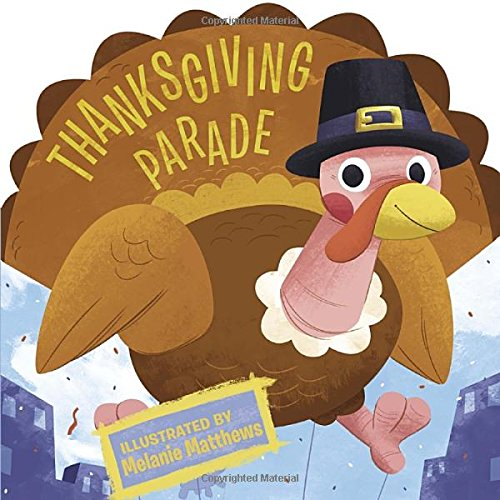What elements on this book cover convey the Thanksgiving theme? The book cover conveys the Thanksgiving theme through the turkey wearing a pilgrim hat and the autumnal colors in the background, emphasizing the harvest season. 